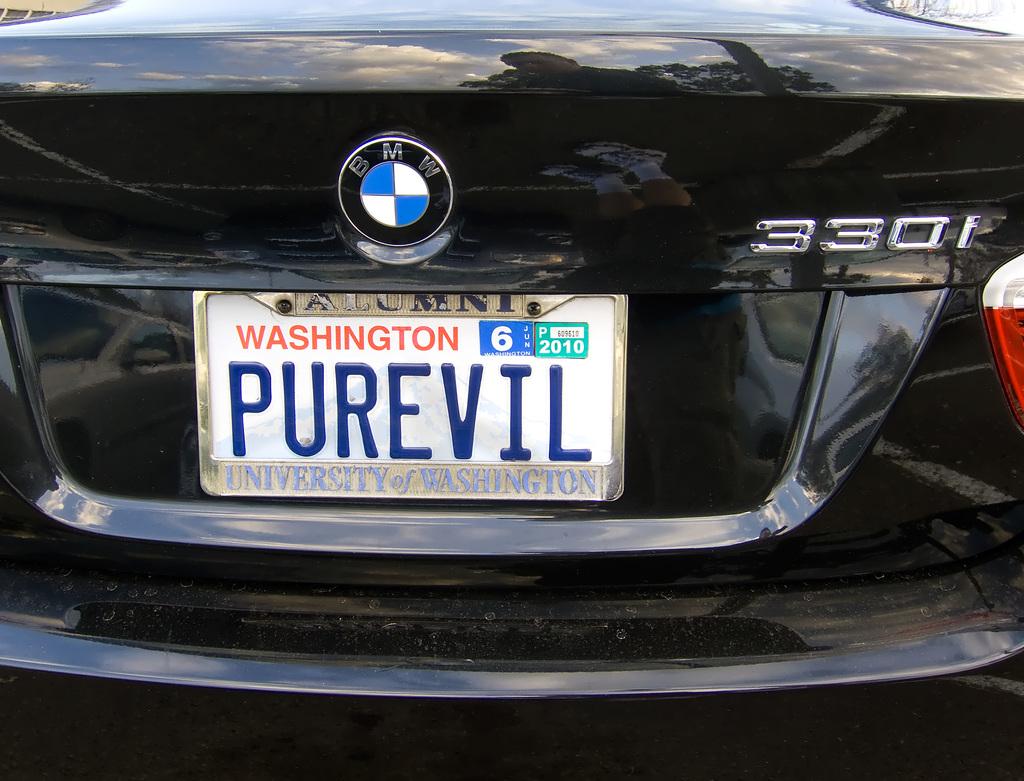What is the model of the vehicle?
Your response must be concise. 330i. What state is this?
Offer a very short reply. Washington. 